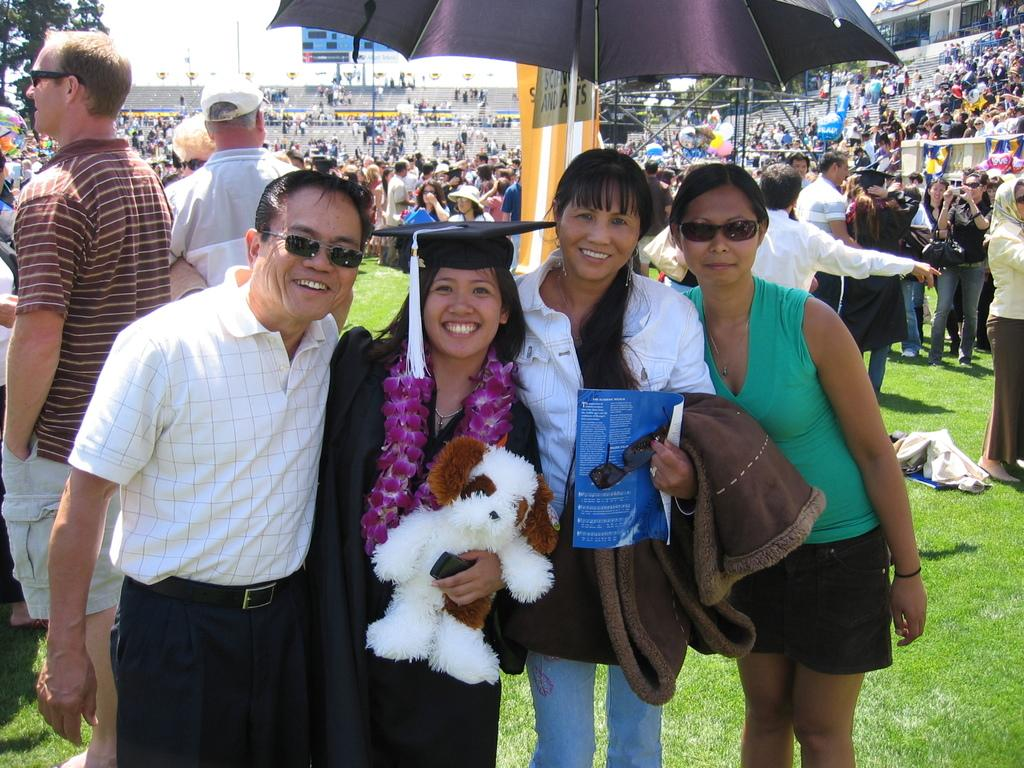How many people are present in the image? There are four people in the image. What are the four people doing in the image? The four people are standing under an umbrella. Can you describe the background of the image? There is a group of people in the background of the image. What type of fly is buzzing around the father's flesh in the image? There is no fly or father present in the image, and therefore no such activity can be observed. 